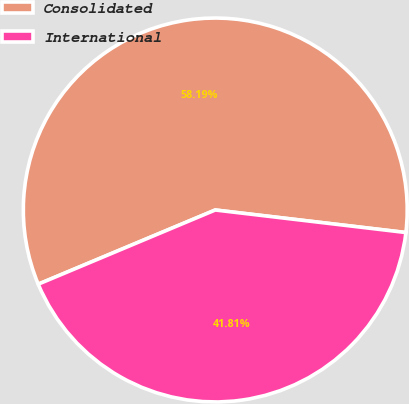Convert chart to OTSL. <chart><loc_0><loc_0><loc_500><loc_500><pie_chart><fcel>Consolidated<fcel>International<nl><fcel>58.19%<fcel>41.81%<nl></chart> 